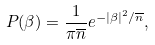Convert formula to latex. <formula><loc_0><loc_0><loc_500><loc_500>P ( \beta ) = \frac { 1 } { \pi \overline { n } } e ^ { - | \beta | ^ { 2 } / \overline { n } } ,</formula> 